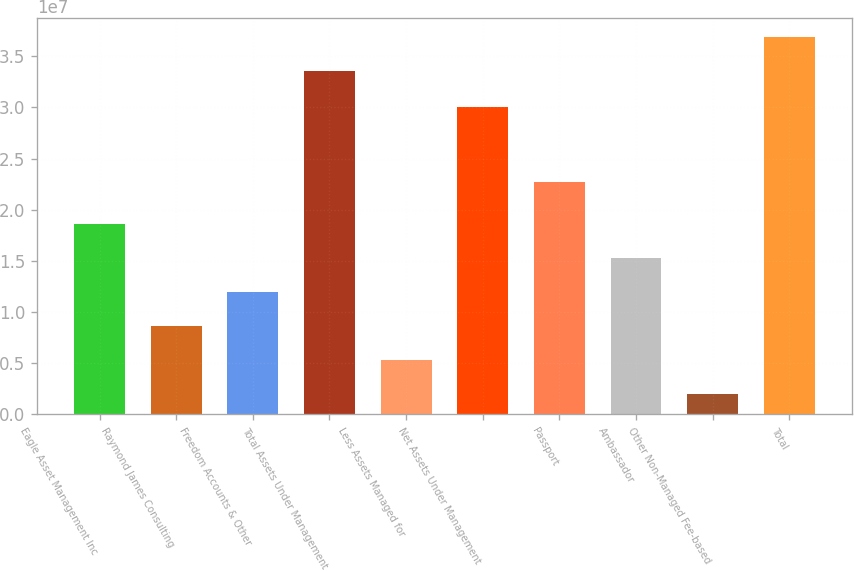<chart> <loc_0><loc_0><loc_500><loc_500><bar_chart><fcel>Eagle Asset Management Inc<fcel>Raymond James Consulting<fcel>Freedom Accounts & Other<fcel>Total Assets Under Management<fcel>Less Assets Managed for<fcel>Net Assets Under Management<fcel>Passport<fcel>Ambassador<fcel>Other Non-Managed Fee-based<fcel>Total<nl><fcel>1.86163e+07<fcel>8.66019e+06<fcel>1.19789e+07<fcel>3.35512e+07<fcel>5.34149e+06<fcel>3.0007e+07<fcel>2.27076e+07<fcel>1.52976e+07<fcel>2.02278e+06<fcel>3.68699e+07<nl></chart> 